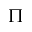<formula> <loc_0><loc_0><loc_500><loc_500>\Pi</formula> 